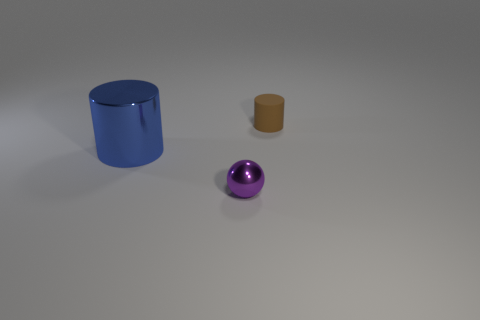Add 3 tiny purple balls. How many objects exist? 6 Subtract all balls. How many objects are left? 2 Subtract all big purple rubber spheres. Subtract all blue cylinders. How many objects are left? 2 Add 3 tiny purple metal balls. How many tiny purple metal balls are left? 4 Add 3 small purple metal spheres. How many small purple metal spheres exist? 4 Subtract 0 cyan cubes. How many objects are left? 3 